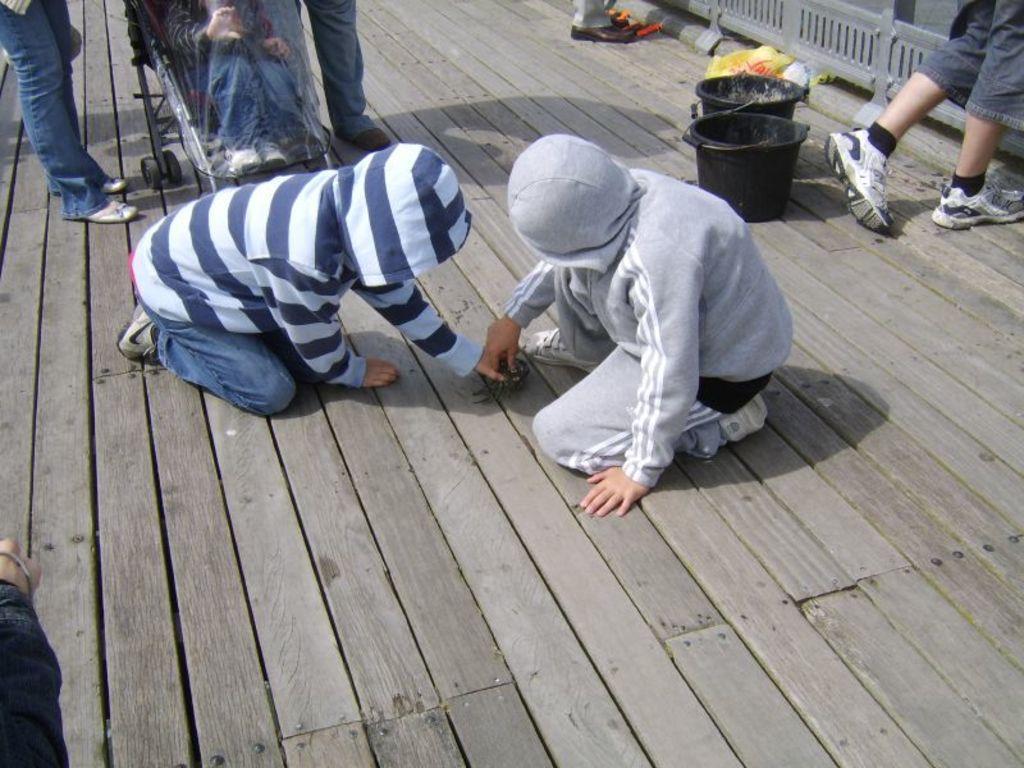How would you summarize this image in a sentence or two? In this picture there are two kids sitting on a wooden floor and holding an object in their hands and there are few people standing beside them and there are few buckets in the right top corner and there is a hand of a person in the left bottom corner. 